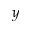<formula> <loc_0><loc_0><loc_500><loc_500>_ { y }</formula> 